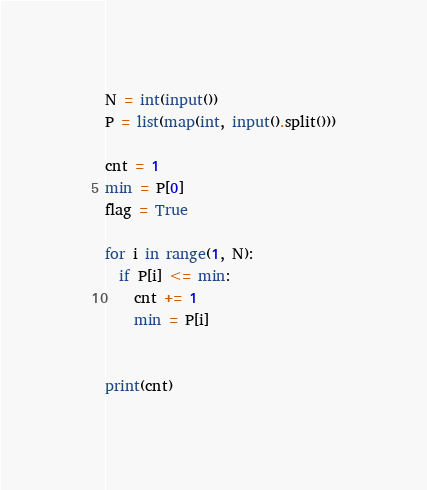Convert code to text. <code><loc_0><loc_0><loc_500><loc_500><_Python_>N = int(input())
P = list(map(int, input().split()))

cnt = 1
min = P[0]
flag = True

for i in range(1, N):
  if P[i] <= min:
    cnt += 1
    min = P[i]
    

print(cnt)</code> 